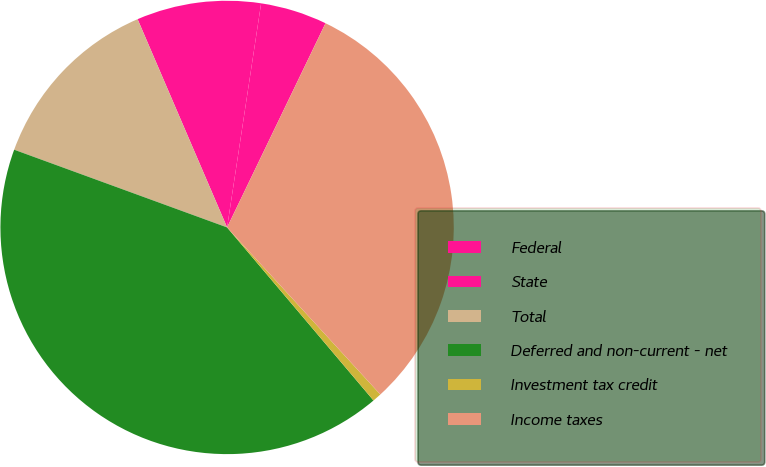Convert chart to OTSL. <chart><loc_0><loc_0><loc_500><loc_500><pie_chart><fcel>Federal<fcel>State<fcel>Total<fcel>Deferred and non-current - net<fcel>Investment tax credit<fcel>Income taxes<nl><fcel>4.75%<fcel>8.86%<fcel>12.97%<fcel>41.75%<fcel>0.64%<fcel>31.04%<nl></chart> 